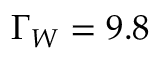<formula> <loc_0><loc_0><loc_500><loc_500>\Gamma _ { W } = 9 . 8</formula> 